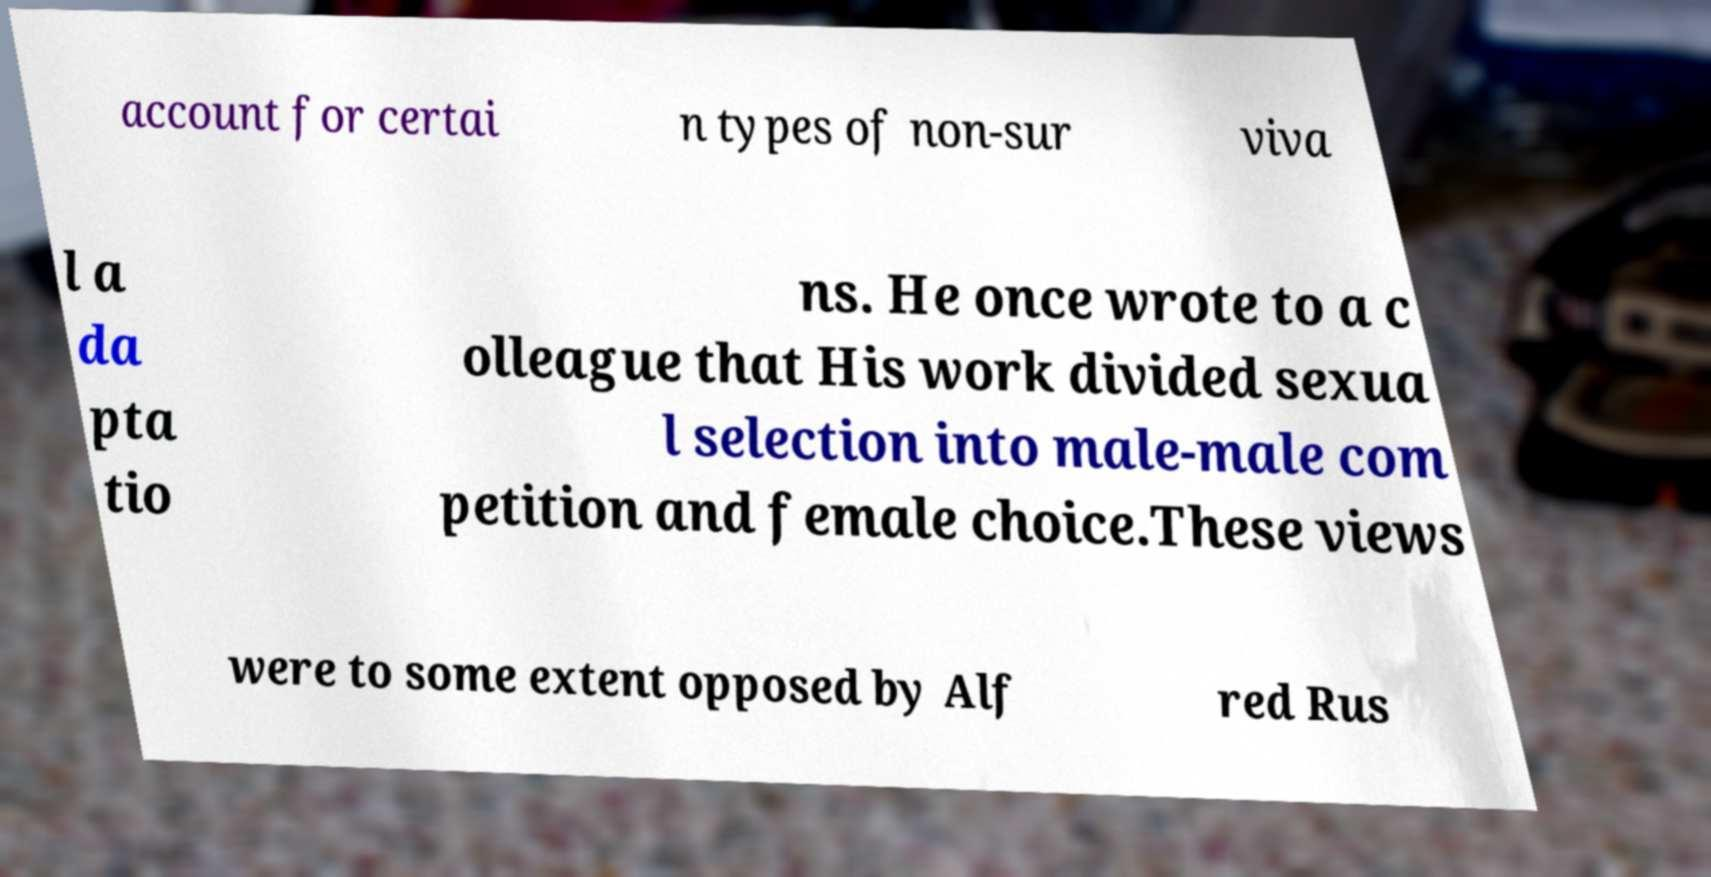For documentation purposes, I need the text within this image transcribed. Could you provide that? account for certai n types of non-sur viva l a da pta tio ns. He once wrote to a c olleague that His work divided sexua l selection into male-male com petition and female choice.These views were to some extent opposed by Alf red Rus 